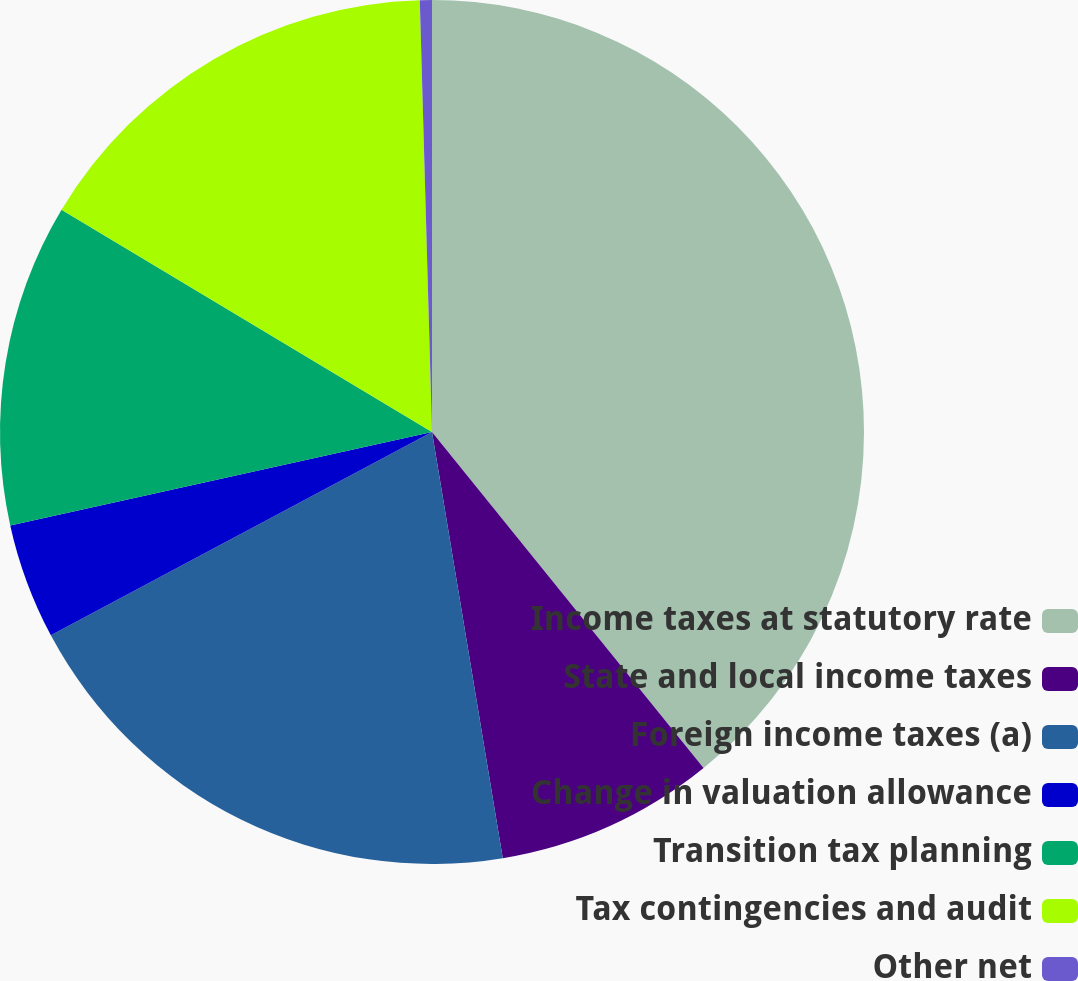<chart> <loc_0><loc_0><loc_500><loc_500><pie_chart><fcel>Income taxes at statutory rate<fcel>State and local income taxes<fcel>Foreign income taxes (a)<fcel>Change in valuation allowance<fcel>Transition tax planning<fcel>Tax contingencies and audit<fcel>Other net<nl><fcel>39.18%<fcel>8.2%<fcel>19.82%<fcel>4.33%<fcel>12.07%<fcel>15.95%<fcel>0.45%<nl></chart> 